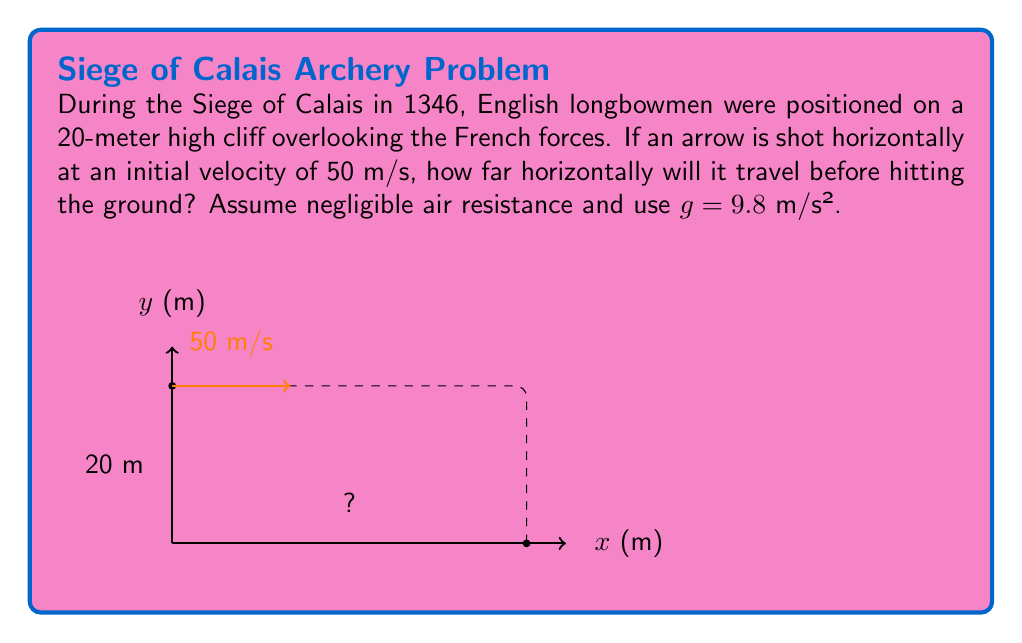Solve this math problem. Let's approach this step-by-step using the equations of motion for projectile motion:

1) In the horizontal direction, there's no acceleration. The distance traveled horizontally is given by:
   $x = v_0t$, where $v_0$ is the initial velocity and $t$ is the time of flight.

2) In the vertical direction, we use the equation:
   $y = y_0 + v_yt - \frac{1}{2}gt^2$
   where $y_0$ is the initial height (20 m), $v_y$ is the initial vertical velocity (0 m/s), and $g$ is the acceleration due to gravity (9.8 m/s²).

3) We want to find the time when the arrow hits the ground, i.e., when $y = 0$:
   $0 = 20 + 0 - \frac{1}{2}(9.8)t^2$

4) Solving for $t$:
   $9.8t^2 = 40$
   $t^2 = \frac{40}{9.8} = 4.08$
   $t = \sqrt{4.08} = 2.02$ seconds

5) Now we can use this time in the horizontal equation:
   $x = 50 \cdot 2.02 = 101$ meters

Therefore, the arrow will travel 101 meters horizontally before hitting the ground.
Answer: 101 m 